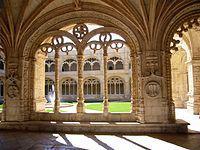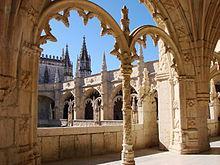The first image is the image on the left, the second image is the image on the right. Analyze the images presented: Is the assertion "In one of the photos, there is at least one tree pictured in front of the buildings." valid? Answer yes or no. No. 